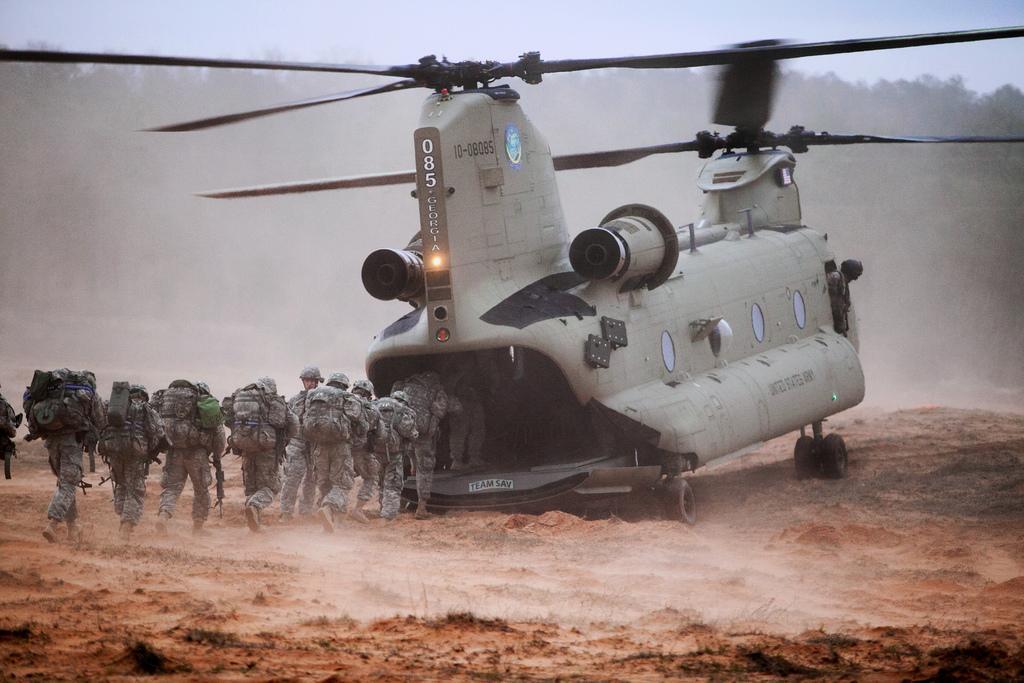How would you summarize this image in a sentence or two? In this picture we can see an airplane on the ground, and few people are running into the airplane, and they wore bags, in the background we can see trees. 